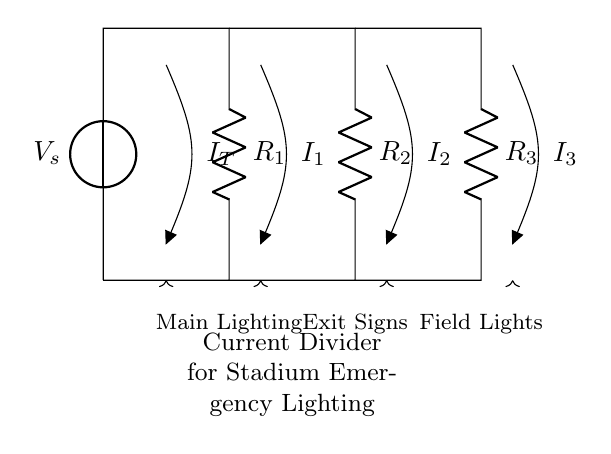What is the total current entering the circuit? The total current entering the circuit, denoted as I_T, is the current supplied by the voltage source, which is represented at the top left of the diagram.
Answer: I_T What components are used in this current divider? The components in the current divider include three resistors (R_1, R_2, R_3) connected in parallel. These resistors are depicted in the circuit diagram.
Answer: Three resistors What are the loads connected to the current divider? The loads connected to the current divider are the Main Lighting, Exit Signs, and Field Lights, which are indicated at the bottom of the diagram.
Answer: Main Lighting, Exit Signs, Field Lights How does the current divide among R_1, R_2, and R_3? The current divides proportionally among the resistors based on their resistance values. As the resistances of each branch differ, the current will be split with less current through higher resistance and more through lower resistance.
Answer: Proportional to resistance Which resistor will have the highest current? The resistor with the lowest resistance will have the highest current, according to the current divider rule. Hence, without specific resistance values, we cannot definitively state which resistor it will be but can infer it based on their resistance ratings.
Answer: Lowest resistance What is the role of this circuit in the rugby stadium? This current divider circuit is crucial for managing power distribution in the emergency lighting system of the rugby stadium, ensuring that all necessary lights are adequately supplied with current during emergencies.
Answer: Power distribution for emergency lighting 